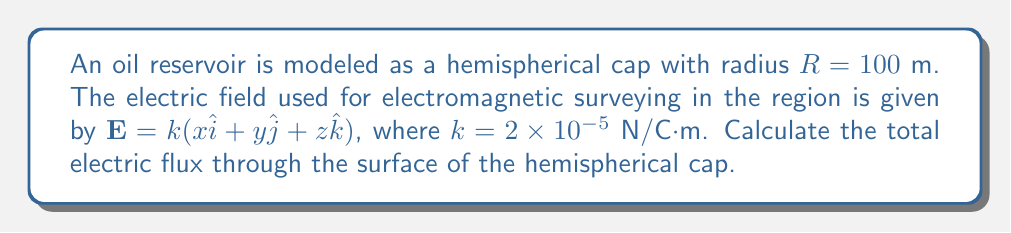Help me with this question. To solve this problem, we'll follow these steps:

1) The flux of an electric field through a surface is given by the surface integral:

   $$\Phi_E = \iint_S \mathbf{E} \cdot d\mathbf{A}$$

2) For a hemisphere, it's easiest to use spherical coordinates. The surface element in spherical coordinates is:

   $$d\mathbf{A} = R^2 \sin\theta d\theta d\phi \hat{r}$$

3) We need to express $\mathbf{E}$ in spherical coordinates:

   $$\mathbf{E} = k(r\sin\theta\cos\phi \hat{i} + r\sin\theta\sin\phi \hat{j} + r\cos\theta \hat{k})$$
   $$\mathbf{E} = kr(\sin\theta\cos\phi \hat{r} + \sin\theta\sin\phi \hat{\theta} + \cos\theta \hat{\phi})$$

4) The dot product $\mathbf{E} \cdot d\mathbf{A}$ simplifies to:

   $$\mathbf{E} \cdot d\mathbf{A} = kR^3 \sin\theta\cos\phi \sin\theta d\theta d\phi$$

5) Now we can set up the integral:

   $$\Phi_E = \int_0^{\pi/2} \int_0^{2\pi} kR^3 \sin^2\theta\cos\phi d\phi d\theta$$

6) Integrate with respect to $\phi$:

   $$\Phi_E = kR^3 \int_0^{\pi/2} \sin^2\theta \left[\int_0^{2\pi} \cos\phi d\phi\right] d\theta$$
   $$\Phi_E = kR^3 \int_0^{\pi/2} \sin^2\theta [0] d\theta = 0$$

7) Substituting the given values:

   $k = 2 \times 10^{-5}$ N/C·m
   $R = 100$ m

   We find that the flux is zero regardless of these values.
Answer: 0 N·m²/C 